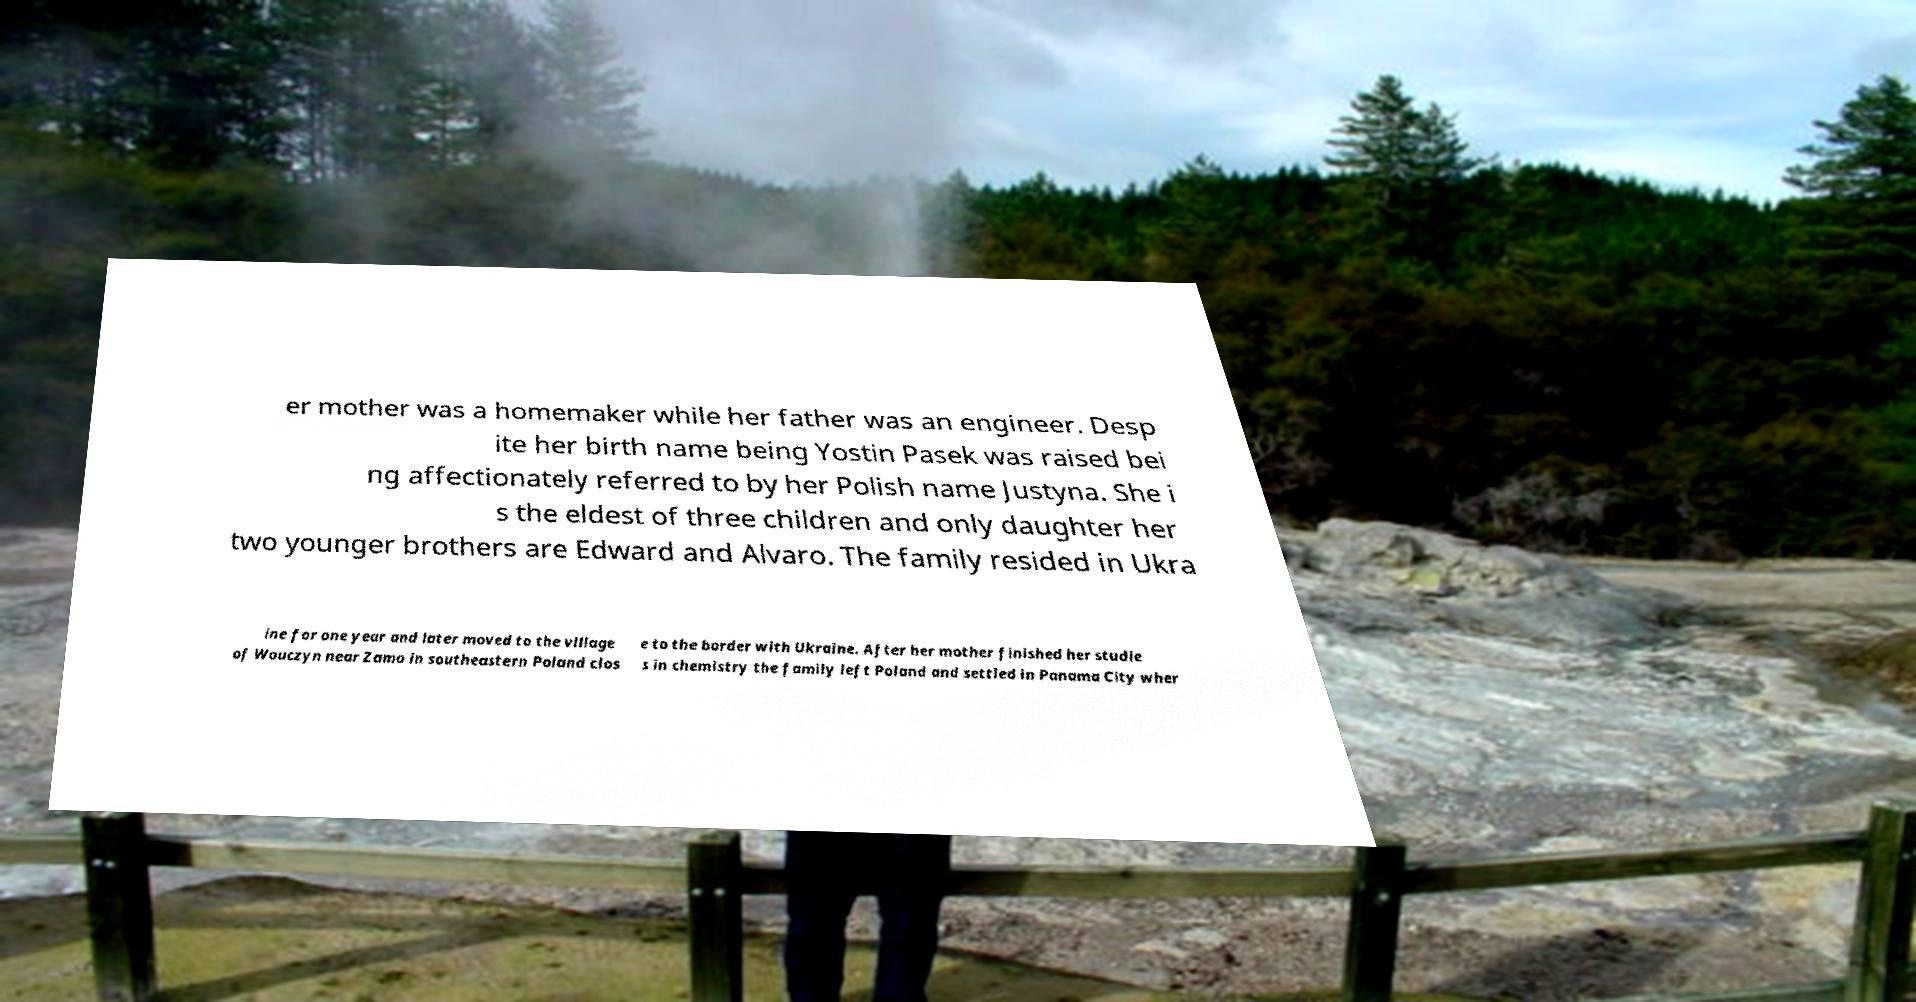Please read and relay the text visible in this image. What does it say? er mother was a homemaker while her father was an engineer. Desp ite her birth name being Yostin Pasek was raised bei ng affectionately referred to by her Polish name Justyna. She i s the eldest of three children and only daughter her two younger brothers are Edward and Alvaro. The family resided in Ukra ine for one year and later moved to the village of Wouczyn near Zamo in southeastern Poland clos e to the border with Ukraine. After her mother finished her studie s in chemistry the family left Poland and settled in Panama City wher 